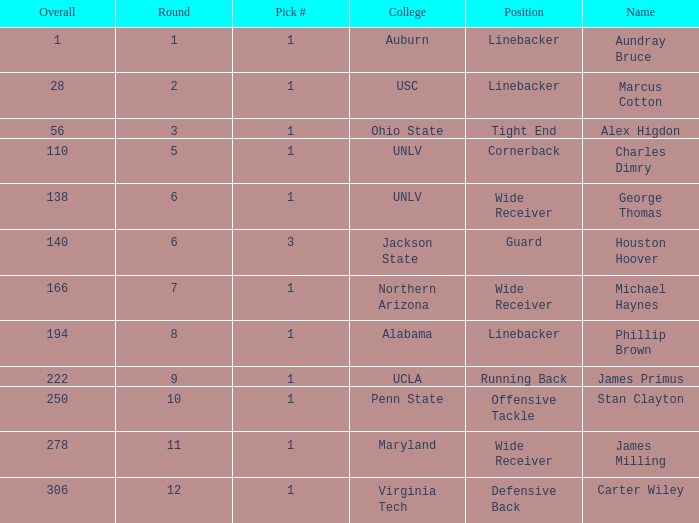In what Round was George Thomas Picked? 6.0. I'm looking to parse the entire table for insights. Could you assist me with that? {'header': ['Overall', 'Round', 'Pick #', 'College', 'Position', 'Name'], 'rows': [['1', '1', '1', 'Auburn', 'Linebacker', 'Aundray Bruce'], ['28', '2', '1', 'USC', 'Linebacker', 'Marcus Cotton'], ['56', '3', '1', 'Ohio State', 'Tight End', 'Alex Higdon'], ['110', '5', '1', 'UNLV', 'Cornerback', 'Charles Dimry'], ['138', '6', '1', 'UNLV', 'Wide Receiver', 'George Thomas'], ['140', '6', '3', 'Jackson State', 'Guard', 'Houston Hoover'], ['166', '7', '1', 'Northern Arizona', 'Wide Receiver', 'Michael Haynes'], ['194', '8', '1', 'Alabama', 'Linebacker', 'Phillip Brown'], ['222', '9', '1', 'UCLA', 'Running Back', 'James Primus'], ['250', '10', '1', 'Penn State', 'Offensive Tackle', 'Stan Clayton'], ['278', '11', '1', 'Maryland', 'Wide Receiver', 'James Milling'], ['306', '12', '1', 'Virginia Tech', 'Defensive Back', 'Carter Wiley']]} 